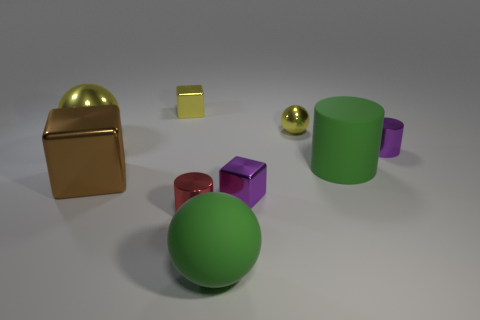Subtract all cylinders. How many objects are left? 6 Subtract all green matte cylinders. How many cylinders are left? 2 Add 1 large green spheres. How many large green spheres exist? 2 Subtract all yellow spheres. How many spheres are left? 1 Subtract 1 purple cubes. How many objects are left? 8 Subtract 2 cubes. How many cubes are left? 1 Subtract all green cylinders. Subtract all yellow spheres. How many cylinders are left? 2 Subtract all brown spheres. How many green cylinders are left? 1 Subtract all large matte objects. Subtract all yellow metallic cubes. How many objects are left? 6 Add 8 large green objects. How many large green objects are left? 10 